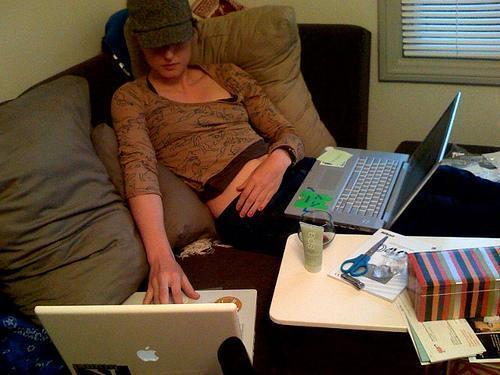Which item might she use on her skin?
Choose the right answer from the provided options to respond to the question.
Options: Box, paper, metal, tube. Tube. 